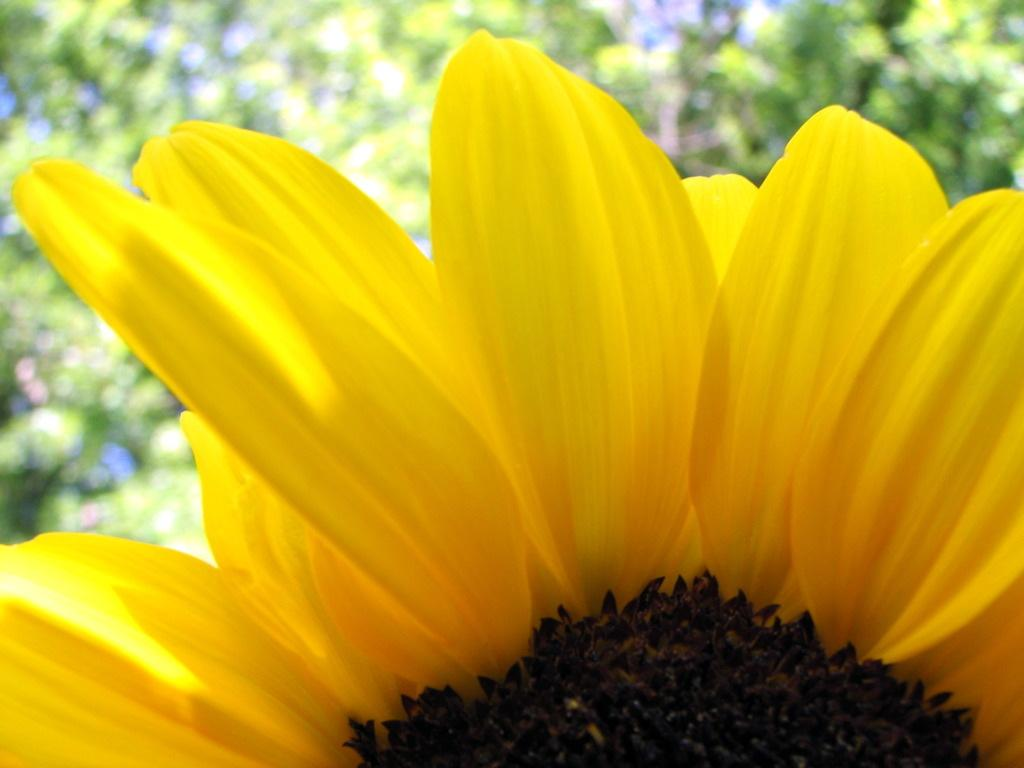What type of flower is visible in the image? There is a yellow flower in the image. Can you describe the background of the image? There are blurred things behind the flower in the image. What type of desk is visible in the image? There is no desk present in the image. What emotion is being expressed by the hill in the image? There is no hill present in the image, and emotions cannot be attributed to inanimate objects like hills. 